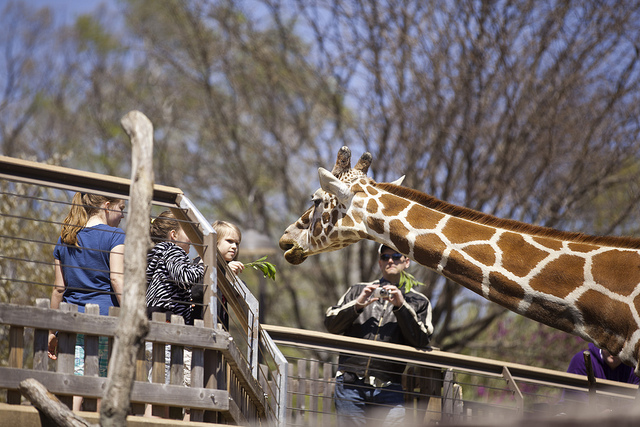What kind of interaction are the people having with the giraffe? The individuals seem to be having a close encounter with the giraffe. Someone is poised to capture the moment on their camera, documenting what is likely a memorable experience of interacting with such a magnificent creature in a controlled environment. 